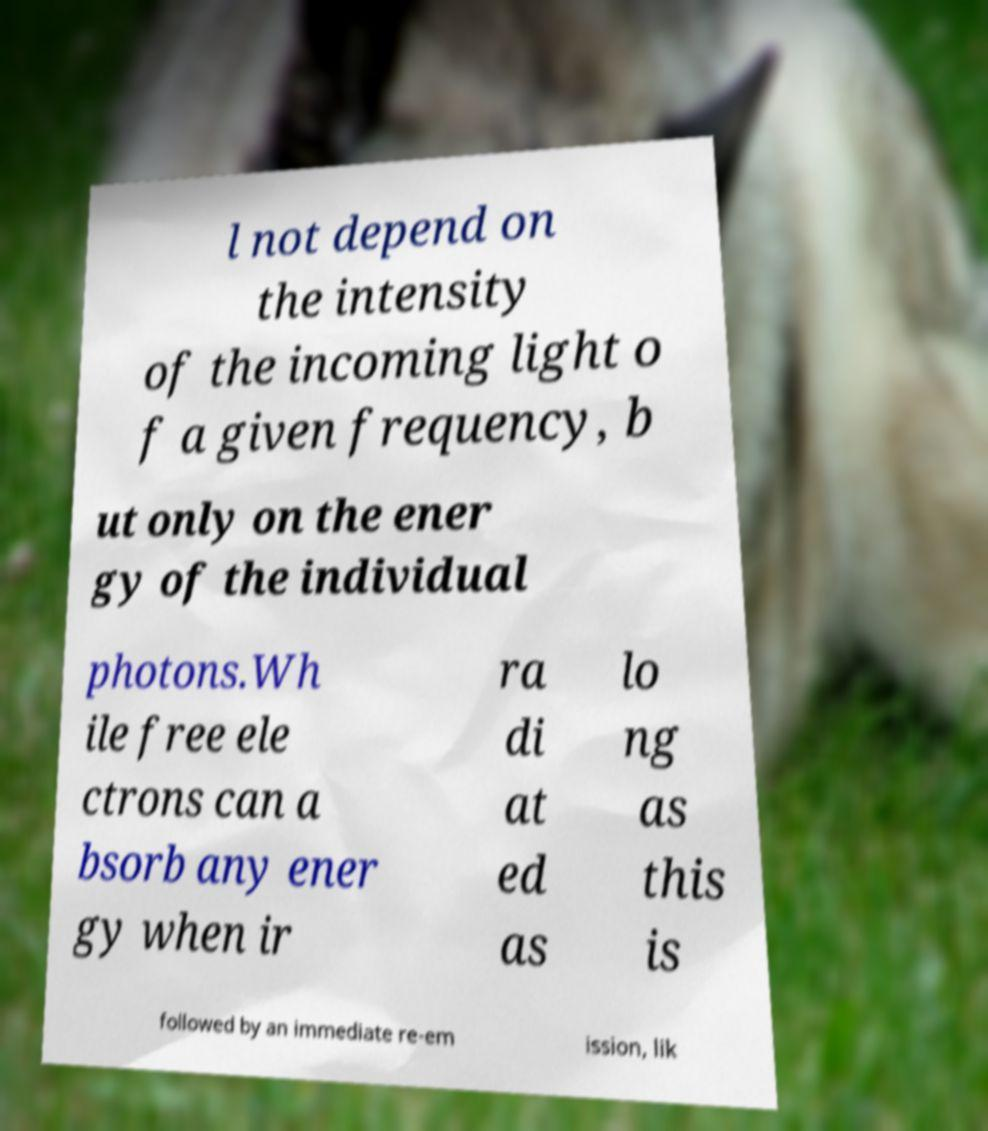Could you extract and type out the text from this image? l not depend on the intensity of the incoming light o f a given frequency, b ut only on the ener gy of the individual photons.Wh ile free ele ctrons can a bsorb any ener gy when ir ra di at ed as lo ng as this is followed by an immediate re-em ission, lik 